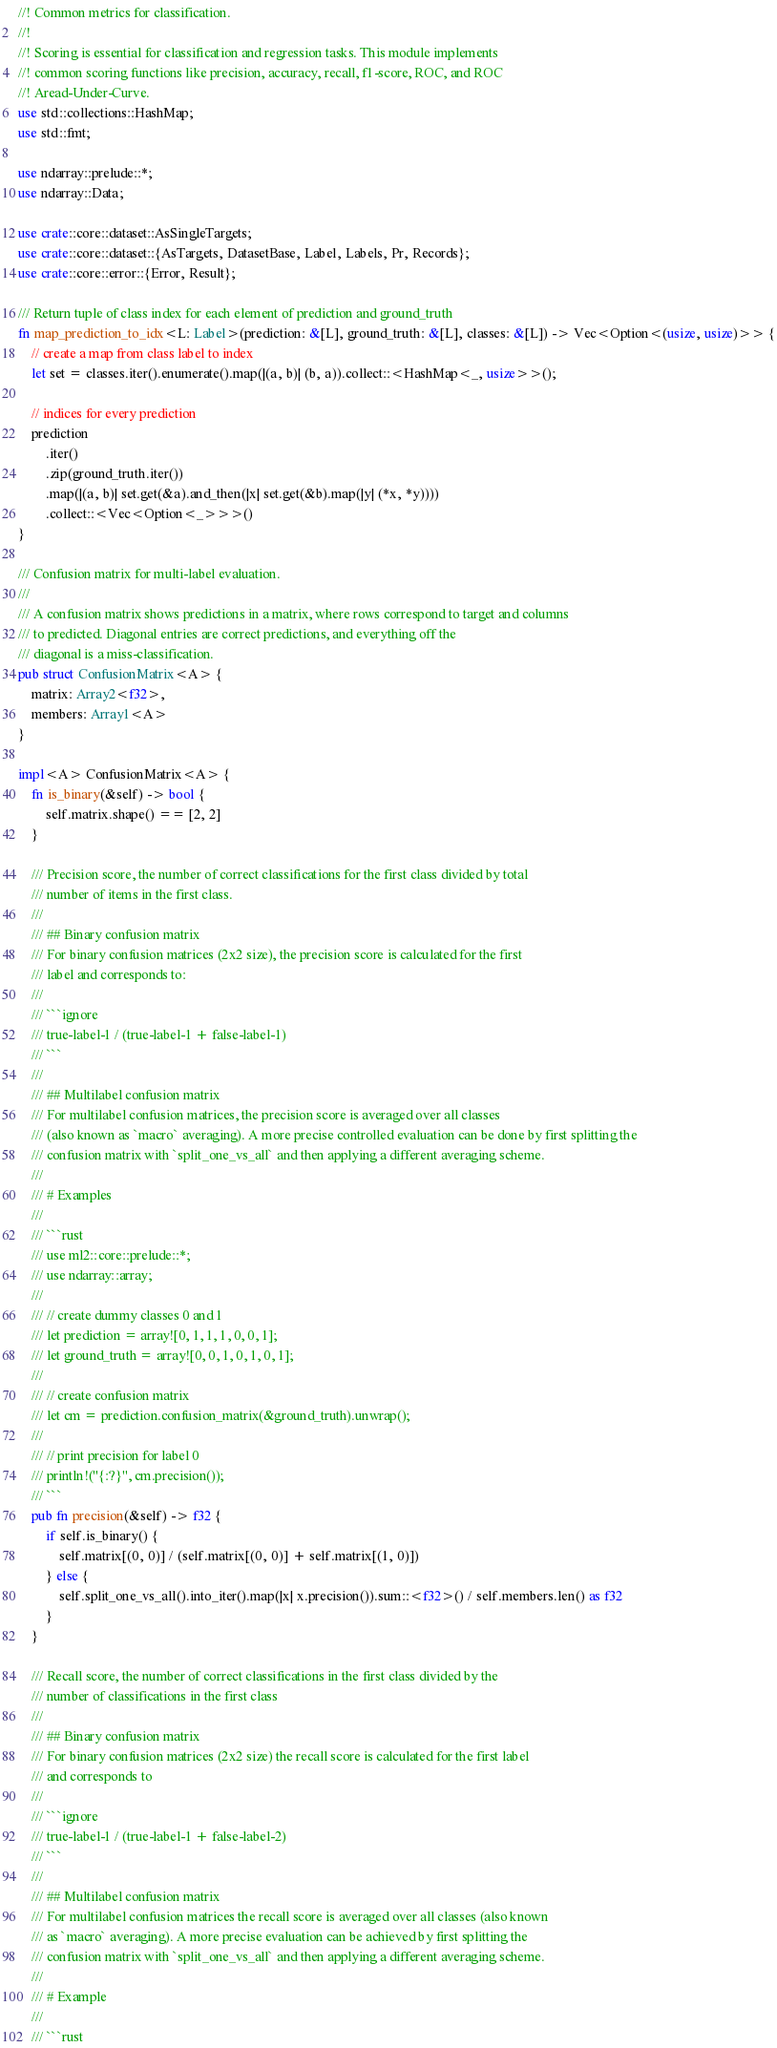<code> <loc_0><loc_0><loc_500><loc_500><_Rust_>//! Common metrics for classification.
//!
//! Scoring is essential for classification and regression tasks. This module implements
//! common scoring functions like precision, accuracy, recall, f1-score, ROC, and ROC
//! Aread-Under-Curve.
use std::collections::HashMap;
use std::fmt;

use ndarray::prelude::*;
use ndarray::Data;

use crate::core::dataset::AsSingleTargets;
use crate::core::dataset::{AsTargets, DatasetBase, Label, Labels, Pr, Records};
use crate::core::error::{Error, Result};

/// Return tuple of class index for each element of prediction and ground_truth
fn map_prediction_to_idx<L: Label>(prediction: &[L], ground_truth: &[L], classes: &[L]) -> Vec<Option<(usize, usize)>> {
	// create a map from class label to index
	let set = classes.iter().enumerate().map(|(a, b)| (b, a)).collect::<HashMap<_, usize>>();

	// indices for every prediction
	prediction
		.iter()
		.zip(ground_truth.iter())
		.map(|(a, b)| set.get(&a).and_then(|x| set.get(&b).map(|y| (*x, *y))))
		.collect::<Vec<Option<_>>>()
}

/// Confusion matrix for multi-label evaluation.
///
/// A confusion matrix shows predictions in a matrix, where rows correspond to target and columns
/// to predicted. Diagonal entries are correct predictions, and everything off the
/// diagonal is a miss-classification.
pub struct ConfusionMatrix<A> {
	matrix: Array2<f32>,
	members: Array1<A>
}

impl<A> ConfusionMatrix<A> {
	fn is_binary(&self) -> bool {
		self.matrix.shape() == [2, 2]
	}

	/// Precision score, the number of correct classifications for the first class divided by total
	/// number of items in the first class.
	///
	/// ## Binary confusion matrix
	/// For binary confusion matrices (2x2 size), the precision score is calculated for the first
	/// label and corresponds to:
	///
	/// ```ignore
	/// true-label-1 / (true-label-1 + false-label-1)
	/// ```
	///
	/// ## Multilabel confusion matrix
	/// For multilabel confusion matrices, the precision score is averaged over all classes
	/// (also known as `macro` averaging). A more precise controlled evaluation can be done by first splitting the
	/// confusion matrix with `split_one_vs_all` and then applying a different averaging scheme.
	///
	/// # Examples
	///
	/// ```rust
	/// use ml2::core::prelude::*;
	/// use ndarray::array;
	///
	/// // create dummy classes 0 and 1
	/// let prediction = array![0, 1, 1, 1, 0, 0, 1];
	/// let ground_truth = array![0, 0, 1, 0, 1, 0, 1];
	///
	/// // create confusion matrix
	/// let cm = prediction.confusion_matrix(&ground_truth).unwrap();
	///
	/// // print precision for label 0
	/// println!("{:?}", cm.precision());
	/// ```
	pub fn precision(&self) -> f32 {
		if self.is_binary() {
			self.matrix[(0, 0)] / (self.matrix[(0, 0)] + self.matrix[(1, 0)])
		} else {
			self.split_one_vs_all().into_iter().map(|x| x.precision()).sum::<f32>() / self.members.len() as f32
		}
	}

	/// Recall score, the number of correct classifications in the first class divided by the
	/// number of classifications in the first class
	///
	/// ## Binary confusion matrix
	/// For binary confusion matrices (2x2 size) the recall score is calculated for the first label
	/// and corresponds to
	///
	/// ```ignore
	/// true-label-1 / (true-label-1 + false-label-2)
	/// ```
	///
	/// ## Multilabel confusion matrix
	/// For multilabel confusion matrices the recall score is averaged over all classes (also known
	/// as `macro` averaging). A more precise evaluation can be achieved by first splitting the
	/// confusion matrix with `split_one_vs_all` and then applying a different averaging scheme.
	///
	/// # Example
	///
	/// ```rust</code> 